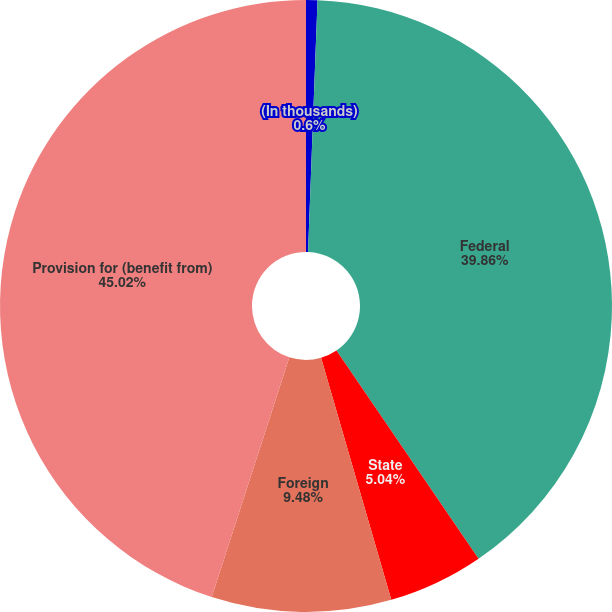Convert chart to OTSL. <chart><loc_0><loc_0><loc_500><loc_500><pie_chart><fcel>(In thousands)<fcel>Federal<fcel>State<fcel>Foreign<fcel>Provision for (benefit from)<nl><fcel>0.6%<fcel>39.86%<fcel>5.04%<fcel>9.48%<fcel>45.01%<nl></chart> 